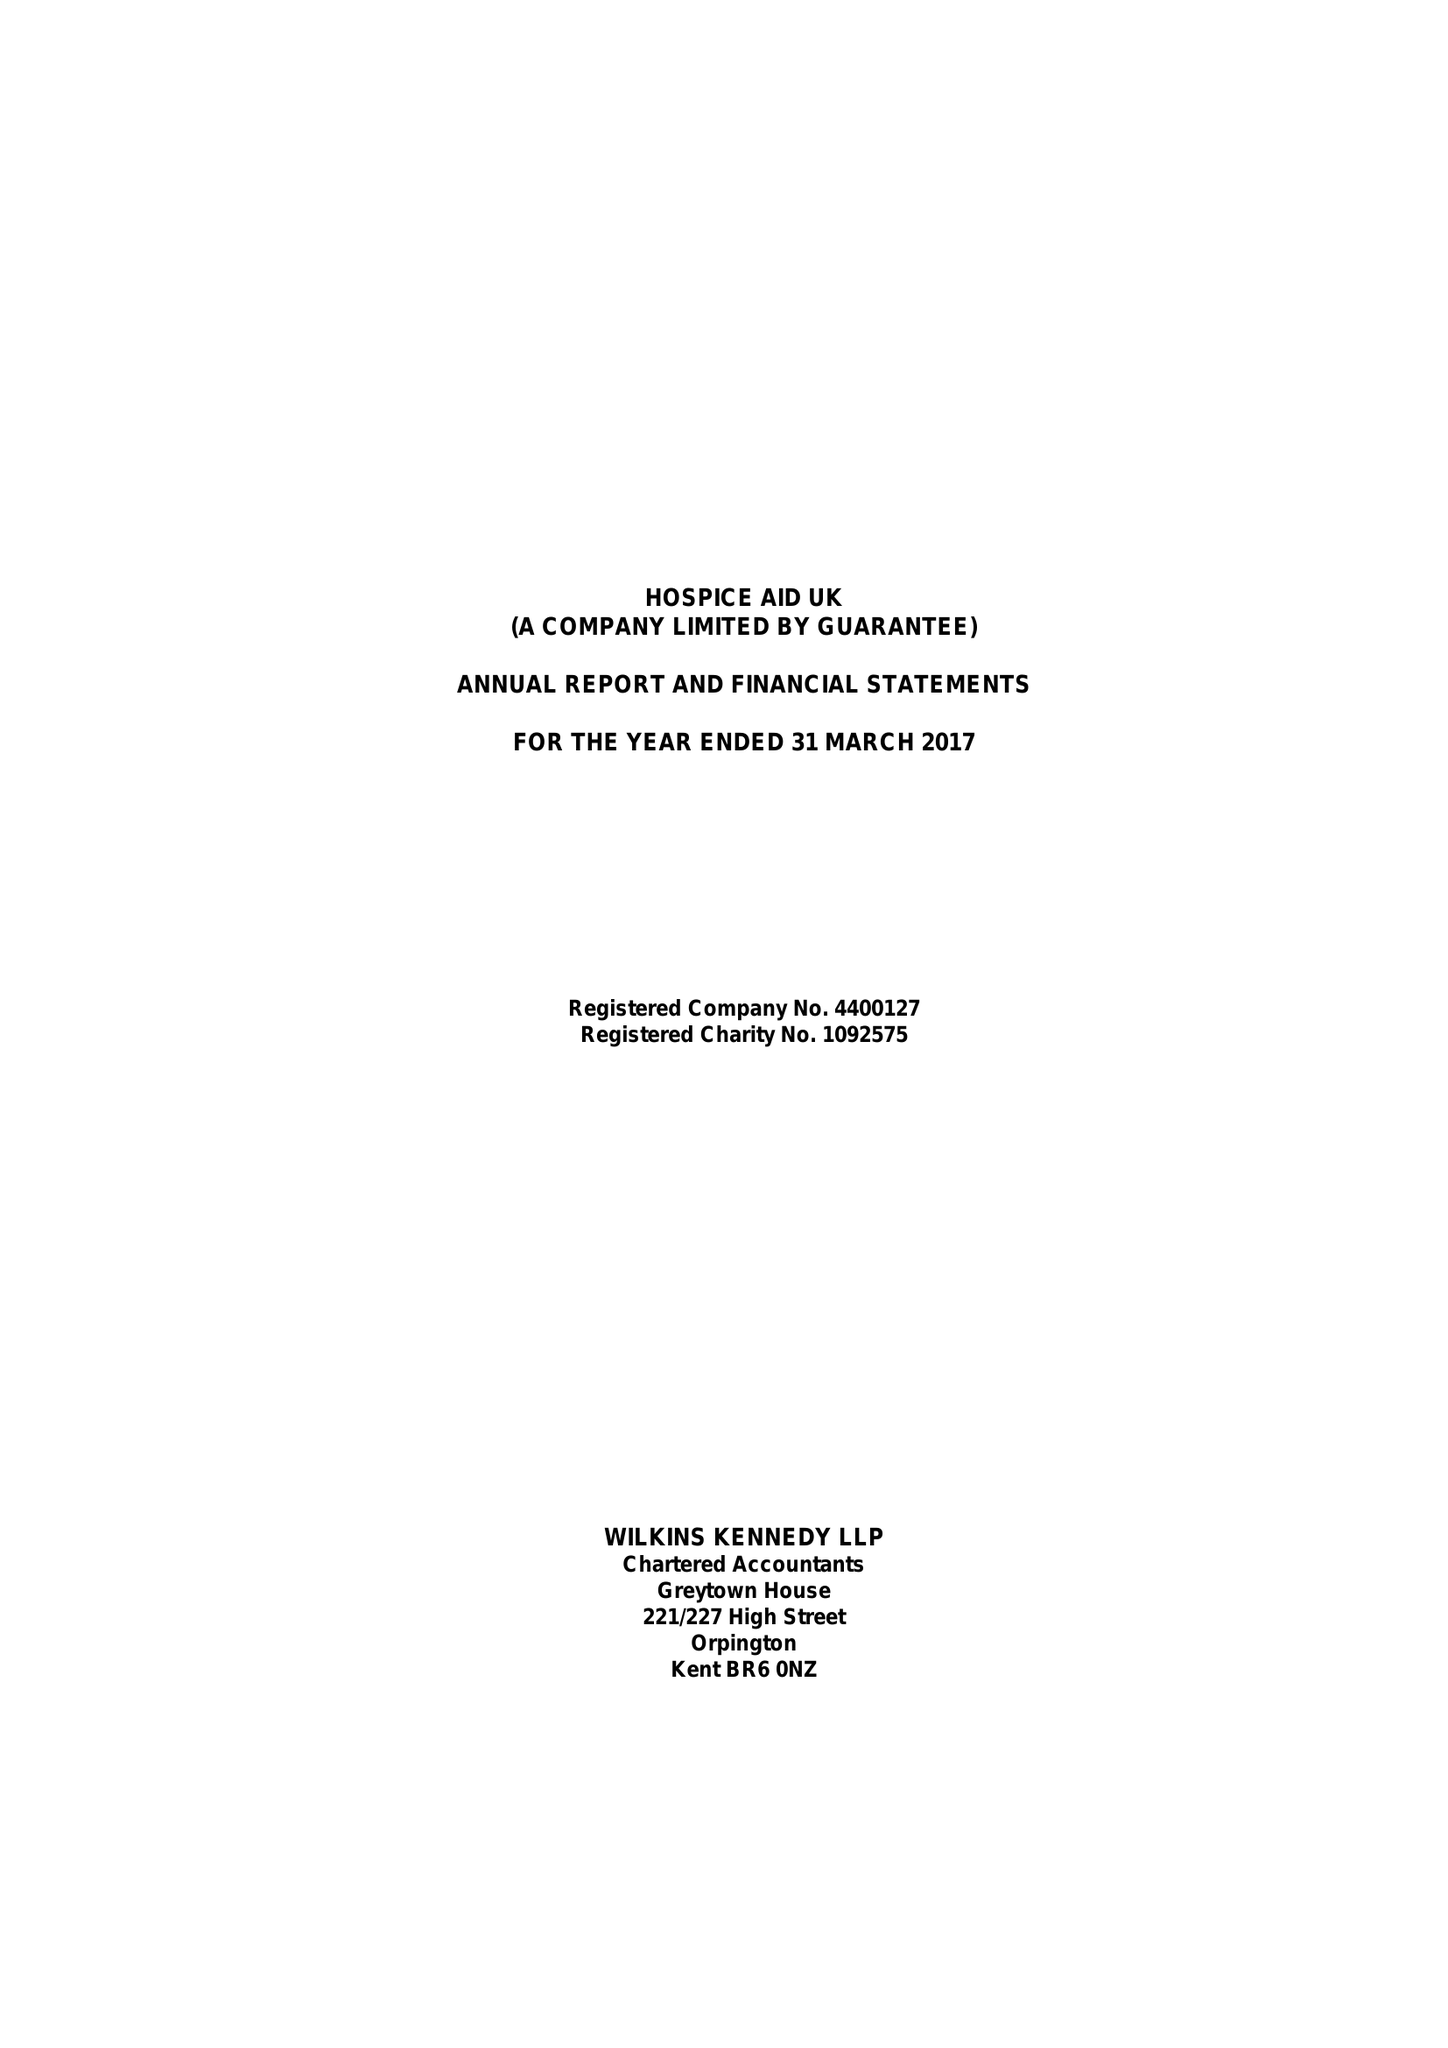What is the value for the report_date?
Answer the question using a single word or phrase. 2017-03-31 